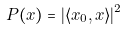Convert formula to latex. <formula><loc_0><loc_0><loc_500><loc_500>P ( x ) = | \langle x _ { 0 } , x \rangle | ^ { 2 }</formula> 